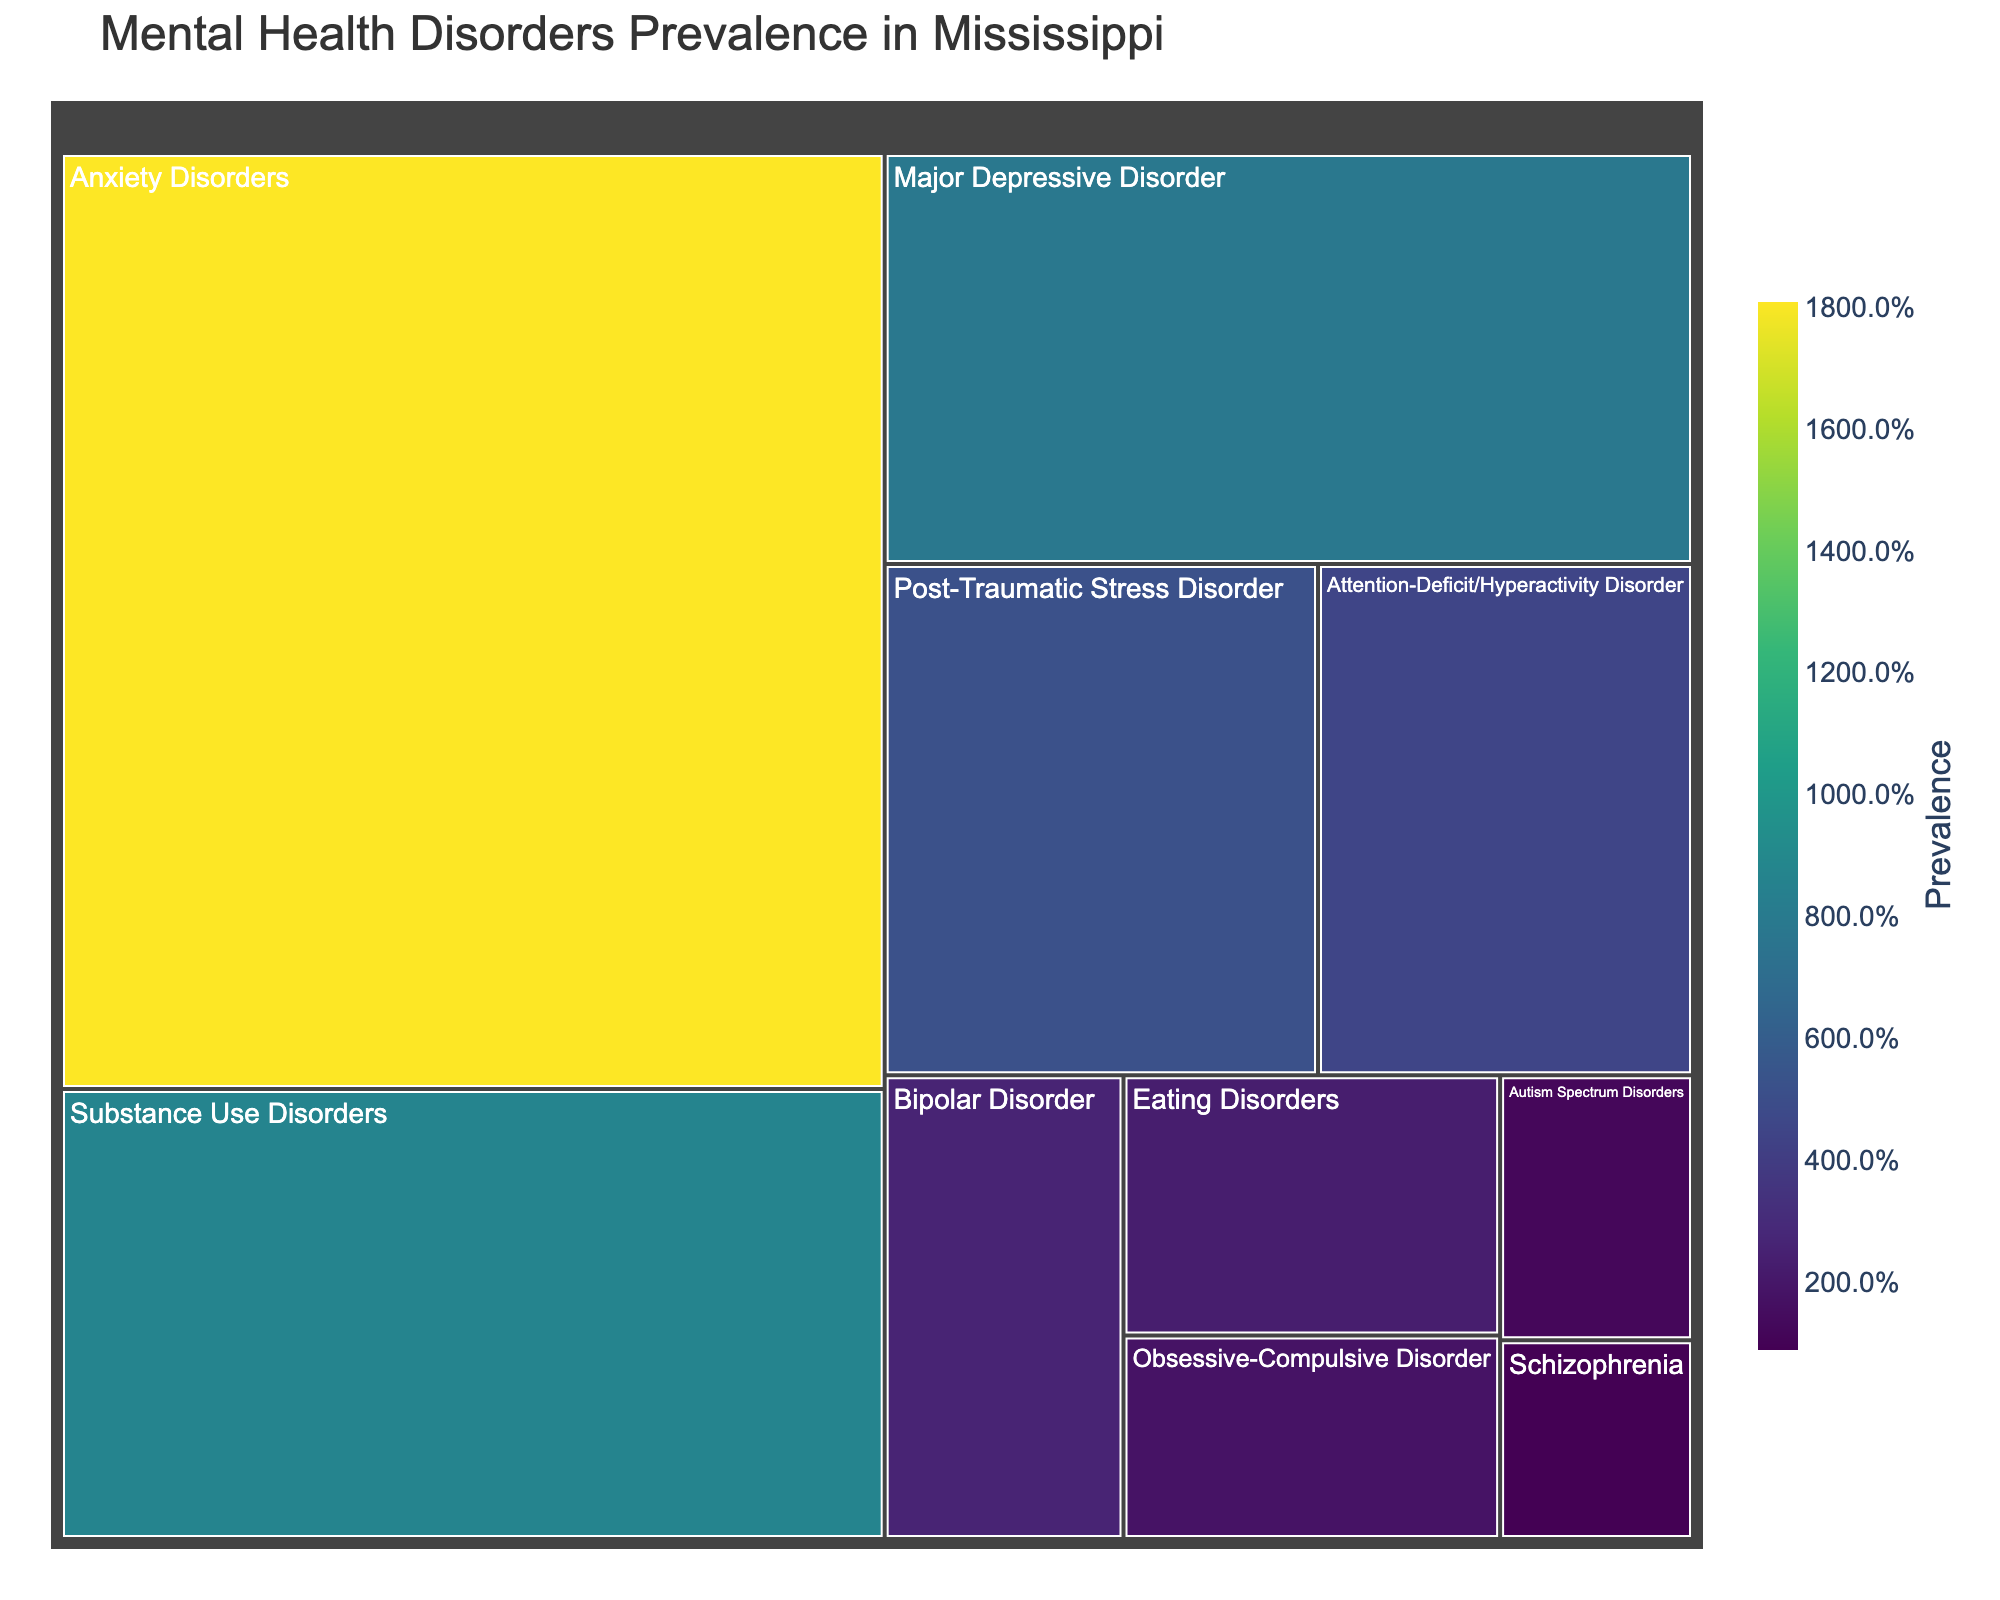what is the title of the figure? The title is always displayed at the top of the figure. Here, you can directly see "Mental Health Disorders Prevalence in Mississippi" at the top.
Answer: Mental Health Disorders Prevalence in Mississippi which condition has the highest prevalence? To determine the condition with the highest prevalence, look at the size of the boxes. The largest box represents the condition with the highest prevalence.
Answer: Anxiety Disorders which condition has the lowest prevalence? The smallest box in the treemap corresponds to the condition with the lowest prevalence, which is evident from the figure.
Answer: Schizophrenia what is the combined prevalence of Major Depressive Disorder and Substance Use Disorders? The combined prevalence can be found by adding the prevalence of Major Depressive Disorder (7.8%) and Substance Use Disorders (8.7%) from the figure.
Answer: 16.5% how does the prevalence of Post-Traumatic Stress Disorder compare to that of Bipolar Disorder? To compare the prevalences, directly view the size or prevalence percentage of both boxes. PTSD has 5.2% and Bipolar Disorder has 2.6%.
Answer: Post-Traumatic Stress Disorder has a higher prevalence than Bipolar Disorder what is the difference in prevalence between Autism Spectrum Disorders and Obsessive-Compulsive Disorder? The difference can be calculated by subtracting the prevalence of Autism Spectrum Disorders (1.2%) from Obsessive-Compulsive Disorder (1.8%).
Answer: 0.6% which conditions have a prevalence higher than Major Depressive Disorder? To find the conditions with a higher prevalence, compare all condition prevalences against Major Depressive Disorder which is 7.8%. Conditions larger than that include Anxiety Disorders and Substance Use Disorders.
Answer: Anxiety Disorders, Substance Use Disorders what is the total prevalence of all conditions combined? To find the total prevalence, sum the prevalences of all conditions: 7.8% + 18.1% + 2.6% + 0.9% + 5.2% + 8.7% + 2.3% + 1.8% + 4.5% + 1.2%.
Answer: 52.1% is the prevalence of Attention-Deficit/Hyperactivity Disorder greater or less than that of Obsessive-Compulsive Disorder? By comparing the sizes or percentages of the relevant boxes, AD/HD (4.5%) is clearly greater than OCD (1.8%).
Answer: Greater what color scale is used in the figure? The color scale used in the figure is stated in its code, but in the visual, it transitions in colors representing different prevalences. Based on the color scale name given, it is Viridis.
Answer: Viridis 